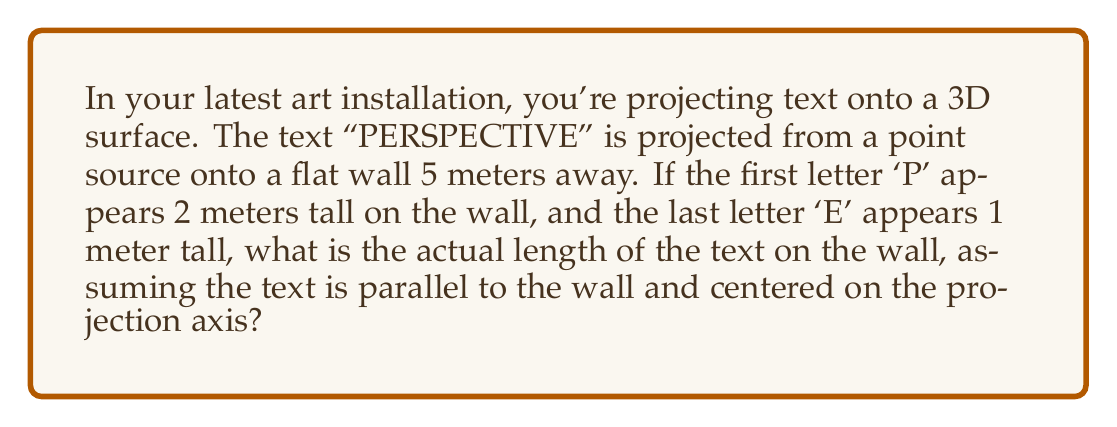Can you answer this question? Let's approach this step-by-step:

1) First, we need to understand the perspective projection. The text appears smaller as it gets further from the center of projection due to perspective distortion.

2) We can model this using similar triangles. Let's define:
   $h_1$ = height of 'P' = 2 m
   $h_2$ = height of 'E' = 1 m
   $D$ = distance from projection point to wall = 5 m
   $L$ = actual length of text on wall (what we're solving for)
   $x$ = half-length of text (since it's centered)

3) The ratio of the heights will be equal to the ratio of their distances from the projection point:

   $$\frac{h_1}{h_2} = \frac{D}{D+L}$$

4) Substituting known values:

   $$\frac{2}{1} = \frac{5}{5+L}$$

5) Cross-multiply:

   $$2(5+L) = 5$$

6) Solve for $L$:

   $$10 + 2L = 5$$
   $$2L = -5$$
   $$L = -2.5$$

7) The negative sign indicates the direction, but we're interested in the magnitude. So, $L = 2.5$ meters.

8) This $L$ represents the distance from the 'P' to the 'E'. To get the full length, we need to double it:

   Total length = $2L = 2(2.5) = 5$ meters

Therefore, the actual length of the text "PERSPECTIVE" on the wall is 5 meters.
Answer: 5 meters 